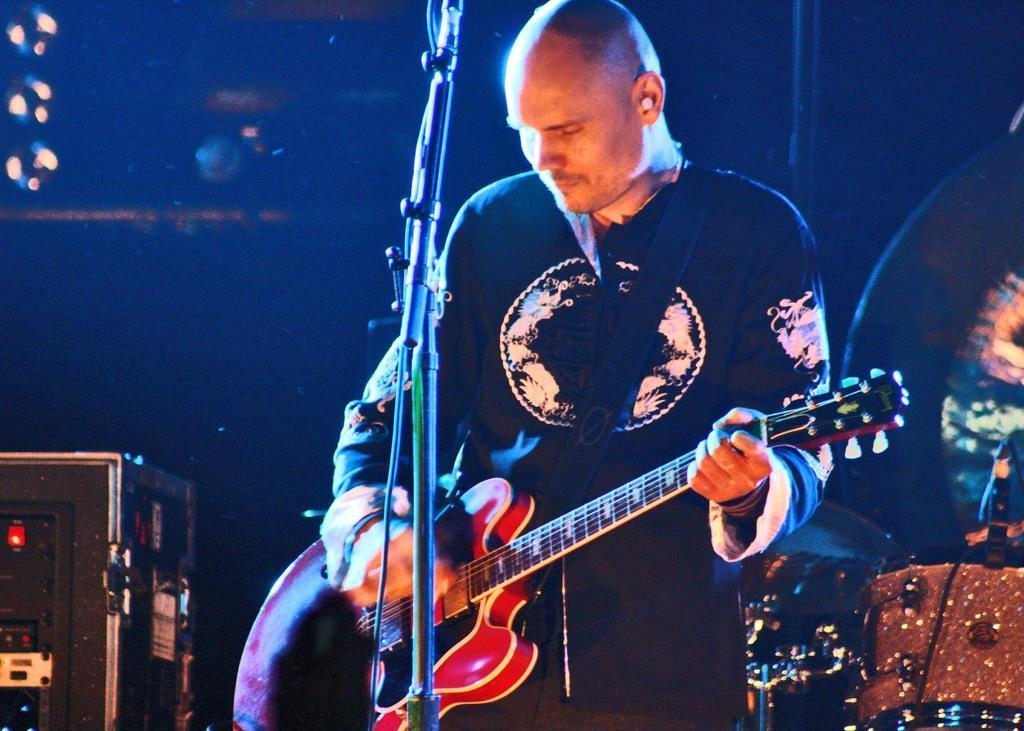Describe this image in one or two sentences. In this image there is a person wearing black color T-shirt playing guitar in front of him there is a microphone and at the left side of the image there is a box. 